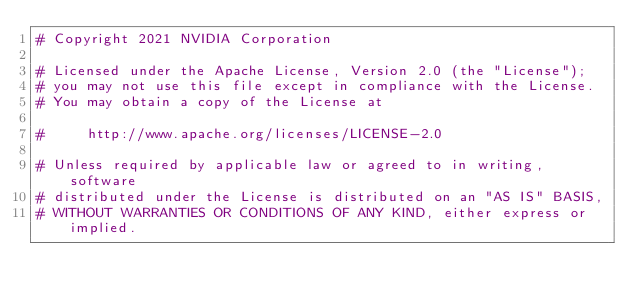<code> <loc_0><loc_0><loc_500><loc_500><_Python_># Copyright 2021 NVIDIA Corporation

# Licensed under the Apache License, Version 2.0 (the "License");
# you may not use this file except in compliance with the License.
# You may obtain a copy of the License at

#     http://www.apache.org/licenses/LICENSE-2.0

# Unless required by applicable law or agreed to in writing, software
# distributed under the License is distributed on an "AS IS" BASIS,
# WITHOUT WARRANTIES OR CONDITIONS OF ANY KIND, either express or implied.</code> 